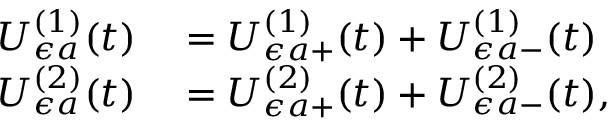Convert formula to latex. <formula><loc_0><loc_0><loc_500><loc_500>\begin{array} { r l } { U _ { \epsilon a } ^ { ( 1 ) } ( t ) } & = U _ { \epsilon a + } ^ { ( 1 ) } ( t ) + U _ { \epsilon a - } ^ { ( 1 ) } ( t ) } \\ { U _ { \epsilon a } ^ { ( 2 ) } ( t ) } & = U _ { \epsilon a + } ^ { ( 2 ) } ( t ) + U _ { \epsilon a - } ^ { ( 2 ) } ( t ) , } \end{array}</formula> 